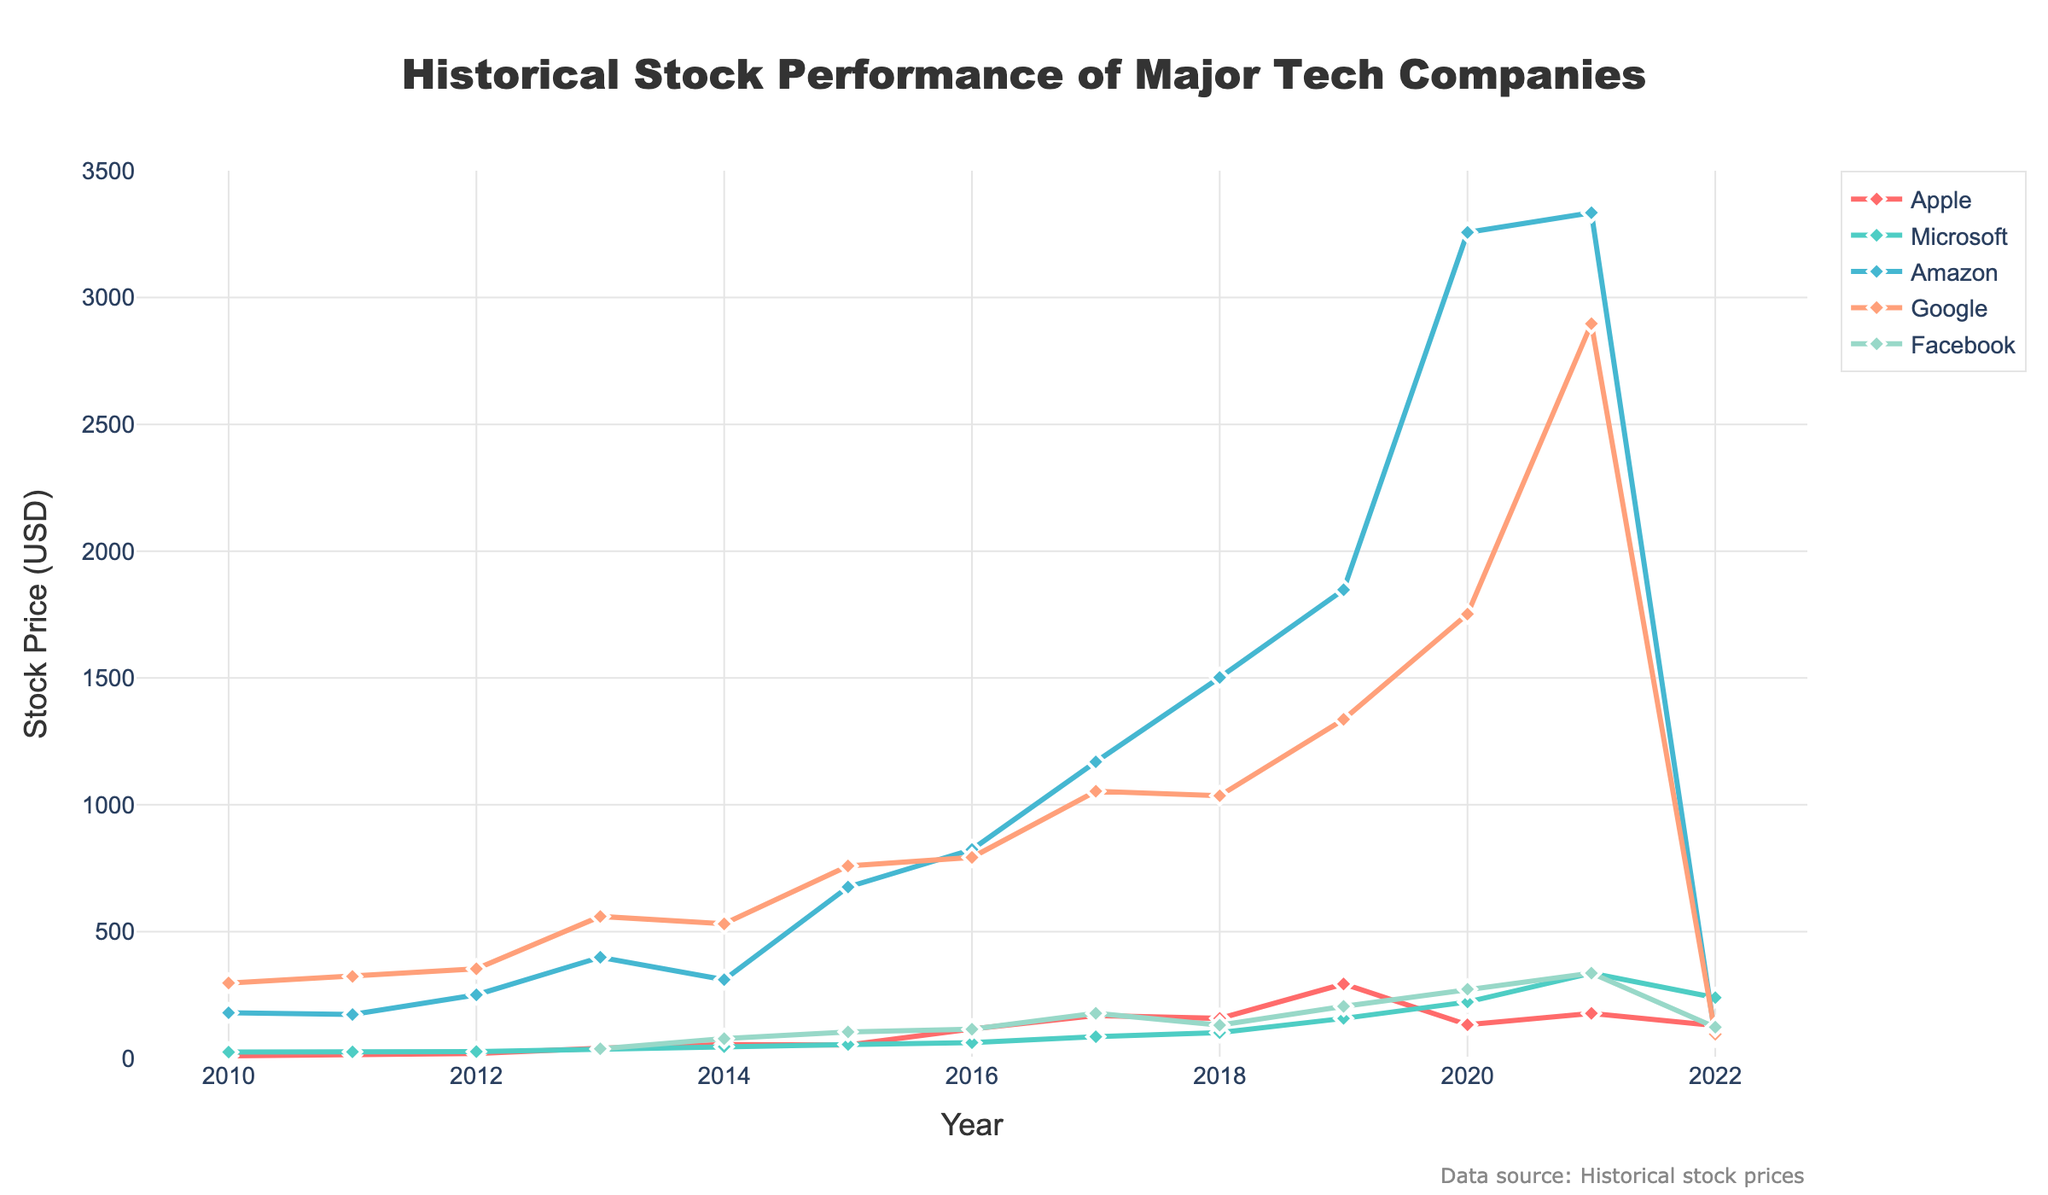What was the stock price of Apple and Microsoft in 2013? To find the stock prices of Apple and Microsoft in 2013, look at the corresponding values on the y-axis for the year 2013. Apple’s stock price is 40.05, and Microsoft’s stock price is 35.98.
Answer: Apple: 40.05, Microsoft: 35.98 Which company had the highest stock price in 2021 and what was it? Examine the data points for the year 2021. Amazon has the highest stock price, which is 3334.34.
Answer: Amazon: 3334.34 How did the stock price of Google change from 2010 to 2020? To determine the change, subtract Google's stock price in 2010 (297.27) from its stock price in 2020 (1751.88). The change is 1751.88 - 297.27 = 1454.61.
Answer: Increase of 1454.61 Between 2015 and 2020, which company experienced the greatest increase in stock price? Calculate the difference in stock prices between 2015 and 2020 for each company: Apple (132.69 - 52.74 = 79.95), Microsoft (222.42 - 55.09 = 167.33), Amazon (3256.93 - 675.89 = 2581.04), Google (1751.88 - 758.88 = 993.00), and Facebook (273.16 - 104.66 = 168.50). Amazon experienced the greatest increase with 2581.04.
Answer: Amazon What is the total stock price sum of Apple, Microsoft, and Amazon in 2018? Add the stock prices of Apple (157.74), Microsoft (101.57), and Amazon (1501.97) for the year 2018. The total sum is 157.74 + 101.57 + 1501.97 = 1761.28.
Answer: 1761.28 Which companies had a decrease in their stock prices from 2021 to 2022? Compare the stock prices in 2021 and 2022 for each company: Apple (177.57 to 129.93), Microsoft (336.32 to 239.82), Amazon (3334.34 to 84.00), Google (2897.04 to 95.46), Facebook (336.35 to 123.18). All the companies had a decrease in their stock prices.
Answer: Apple, Microsoft, Amazon, Google, Facebook Did any company's stock price remain the same from one year to the next? Examine each company's stock prices year by year to see if any remained unchanged. There are no occurrences of a stock price remaining the same from one year to the next.
Answer: No What was the trend of Facebook’s stock price from 2013 to 2022? Observe Facebook's stock price data points from 2013 to 2022. The trend starts with 38.00 in 2013, increases and peaks at 336.35 in 2021, and then drops to 123.18 in 2022. Overall, Facebook’s stock price shows an upward trend followed by a decline.
Answer: Upward then downward Which company had the most stable stock price between 2010 and 2022? To determine stability, check the fluctuation range (difference between the highest and lowest stock prices) for each company: Apple (293.65 - 10.13 = 283.52), Microsoft (336.32 - 25.04 = 311.28), Amazon (3334.34 - 84.00 = 3250.34), Google (2897.04 - 95.46 = 2801.58), Facebook (336.35 - 38.00 = 298.35). Apple has the smallest fluctuation range (283.52), indicating the most stable stock price.
Answer: Apple 